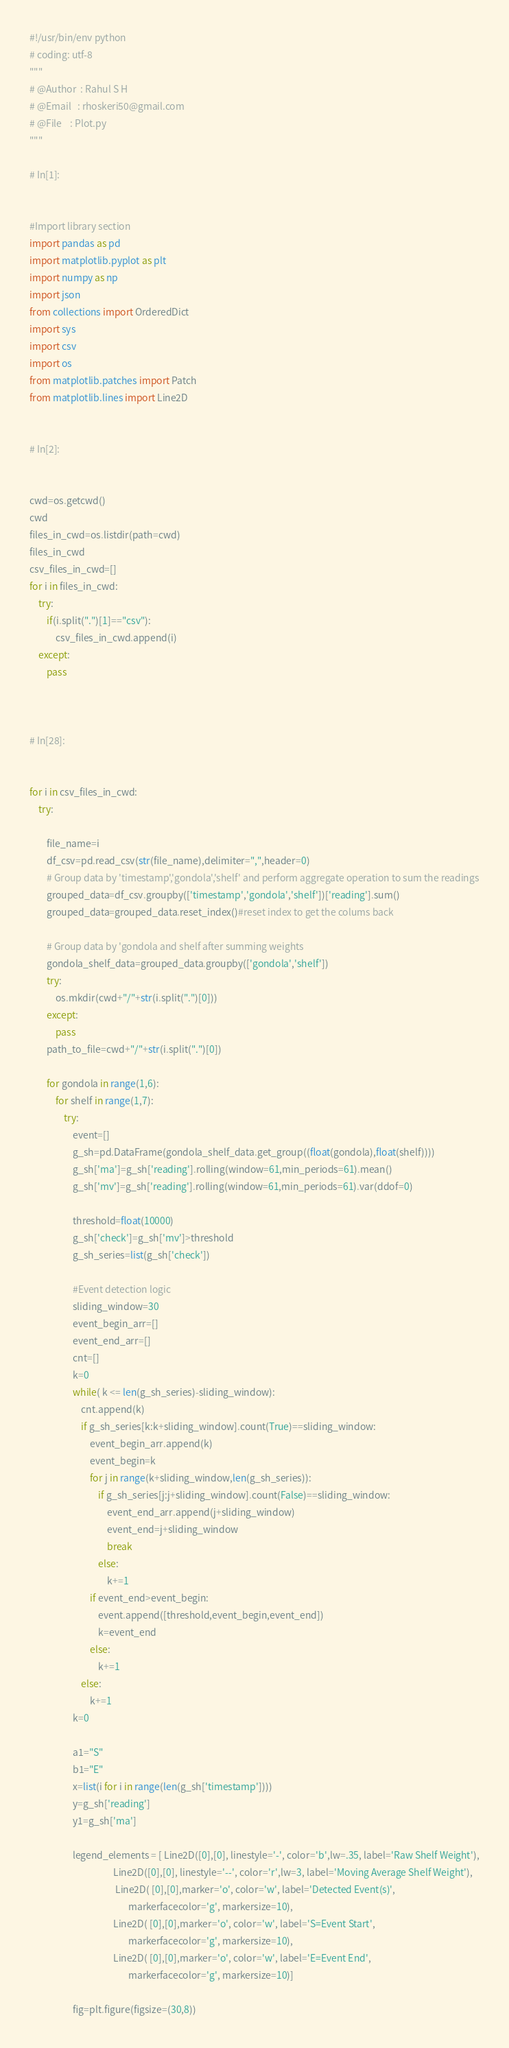Convert code to text. <code><loc_0><loc_0><loc_500><loc_500><_Python_>#!/usr/bin/env python
# coding: utf-8
"""
# @Author  : Rahul S H
# @Email   : rhoskeri50@gmail.com
# @File    : Plot.py
"""

# In[1]:


#Import library section
import pandas as pd
import matplotlib.pyplot as plt
import numpy as np
import json
from collections import OrderedDict
import sys
import csv
import os
from matplotlib.patches import Patch
from matplotlib.lines import Line2D


# In[2]:


cwd=os.getcwd()
cwd
files_in_cwd=os.listdir(path=cwd)
files_in_cwd
csv_files_in_cwd=[]
for i in files_in_cwd:
    try:
        if(i.split(".")[1]=="csv"):
            csv_files_in_cwd.append(i)
    except:
        pass



# In[28]:


for i in csv_files_in_cwd:
    try:
        
        file_name=i
        df_csv=pd.read_csv(str(file_name),delimiter=",",header=0)
        # Group data by 'timestamp','gondola','shelf' and perform aggregate operation to sum the readings
        grouped_data=df_csv.groupby(['timestamp','gondola','shelf'])['reading'].sum()
        grouped_data=grouped_data.reset_index()#reset index to get the colums back

        # Group data by 'gondola and shelf after summing weights
        gondola_shelf_data=grouped_data.groupby(['gondola','shelf'])
        try:
            os.mkdir(cwd+"/"+str(i.split(".")[0]))
        except:
            pass
        path_to_file=cwd+"/"+str(i.split(".")[0])
        
        for gondola in range(1,6):
            for shelf in range(1,7):
                try:
                    event=[]
                    g_sh=pd.DataFrame(gondola_shelf_data.get_group((float(gondola),float(shelf))))
                    g_sh['ma']=g_sh['reading'].rolling(window=61,min_periods=61).mean()
                    g_sh['mv']=g_sh['reading'].rolling(window=61,min_periods=61).var(ddof=0)
                    
                    threshold=float(10000)
                    g_sh['check']=g_sh['mv']>threshold
                    g_sh_series=list(g_sh['check']) 

                    #Event detection logic
                    sliding_window=30
                    event_begin_arr=[]
                    event_end_arr=[]
                    cnt=[]
                    k=0
                    while( k <= len(g_sh_series)-sliding_window):
                        cnt.append(k)
                        if g_sh_series[k:k+sliding_window].count(True)==sliding_window:
                            event_begin_arr.append(k)
                            event_begin=k
                            for j in range(k+sliding_window,len(g_sh_series)):
                                if g_sh_series[j:j+sliding_window].count(False)==sliding_window:
                                    event_end_arr.append(j+sliding_window)
                                    event_end=j+sliding_window
                                    break
                                else:
                                    k+=1
                            if event_end>event_begin:
                                event.append([threshold,event_begin,event_end])
                                k=event_end
                            else:
                                k+=1
                        else:
                            k+=1
                    k=0
                    
                    a1="S"
                    b1="E"
                    x=list(i for i in range(len(g_sh['timestamp'])))
                    y=g_sh['reading']
                    y1=g_sh['ma']
                    
                    legend_elements = [ Line2D([0],[0], linestyle='-', color='b',lw=.35, label='Raw Shelf Weight'),
                                       Line2D([0],[0], linestyle='--', color='r',lw=3, label='Moving Average Shelf Weight'),
                                        Line2D( [0],[0],marker='o', color='w', label='Detected Event(s)',
                                              markerfacecolor='g', markersize=10),
                                       Line2D( [0],[0],marker='o', color='w', label='S=Event Start',
                                              markerfacecolor='g', markersize=10),
                                       Line2D( [0],[0],marker='o', color='w', label='E=Event End',
                                              markerfacecolor='g', markersize=10)]
                    
                    fig=plt.figure(figsize=(30,8))</code> 